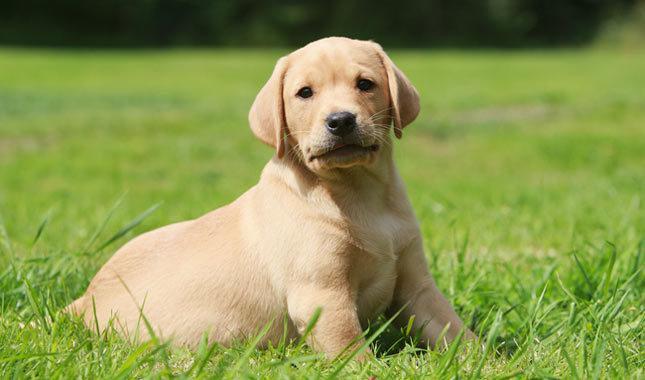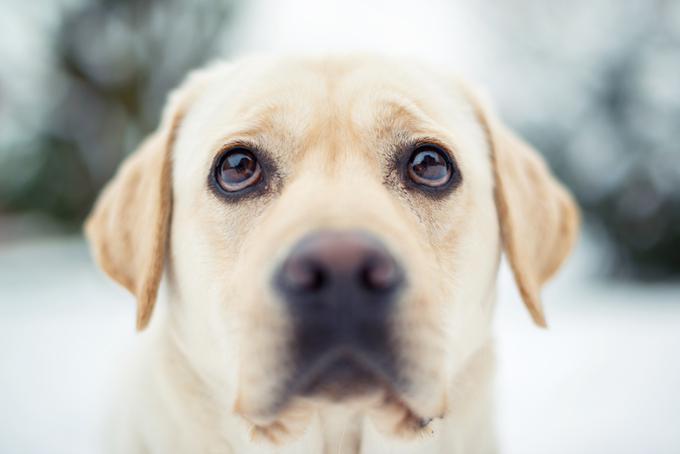The first image is the image on the left, the second image is the image on the right. For the images shown, is this caption "Images show foreground dogs in profile on grass with bodies in opposite directions." true? Answer yes or no. No. The first image is the image on the left, the second image is the image on the right. Given the left and right images, does the statement "There are two dogs" hold true? Answer yes or no. Yes. 